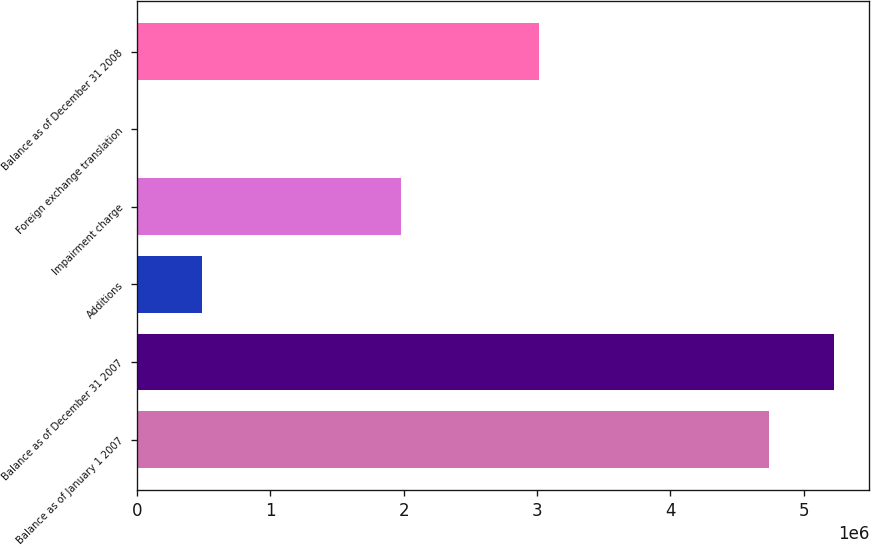Convert chart to OTSL. <chart><loc_0><loc_0><loc_500><loc_500><bar_chart><fcel>Balance as of January 1 2007<fcel>Balance as of December 31 2007<fcel>Additions<fcel>Impairment charge<fcel>Foreign exchange translation<fcel>Balance as of December 31 2008<nl><fcel>4.7407e+06<fcel>5.22749e+06<fcel>490561<fcel>1.982e+06<fcel>3765<fcel>3.0174e+06<nl></chart> 